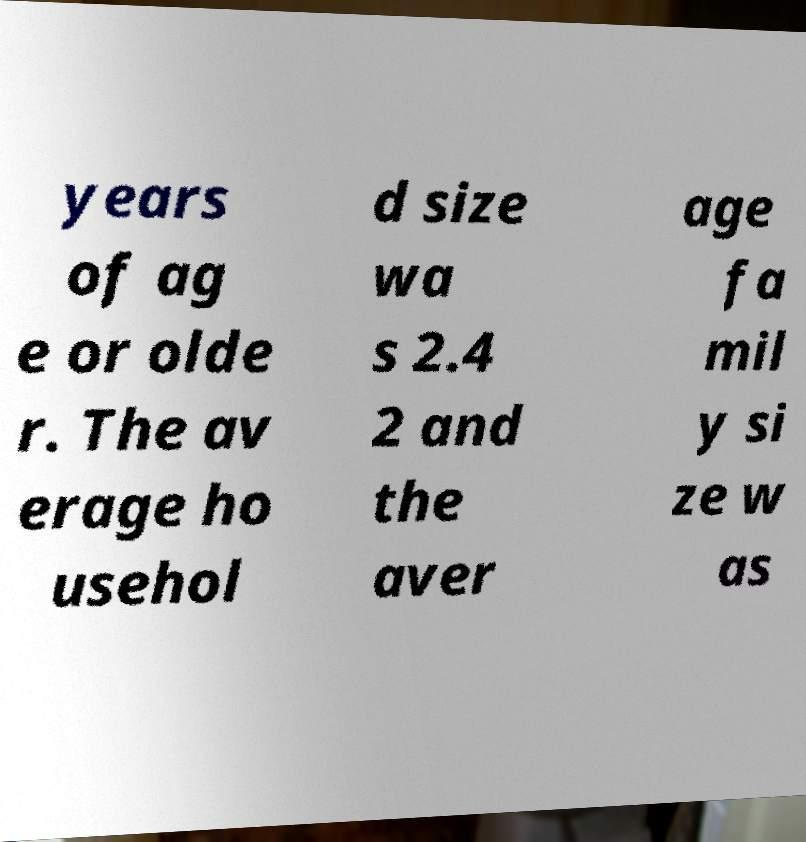Could you assist in decoding the text presented in this image and type it out clearly? years of ag e or olde r. The av erage ho usehol d size wa s 2.4 2 and the aver age fa mil y si ze w as 